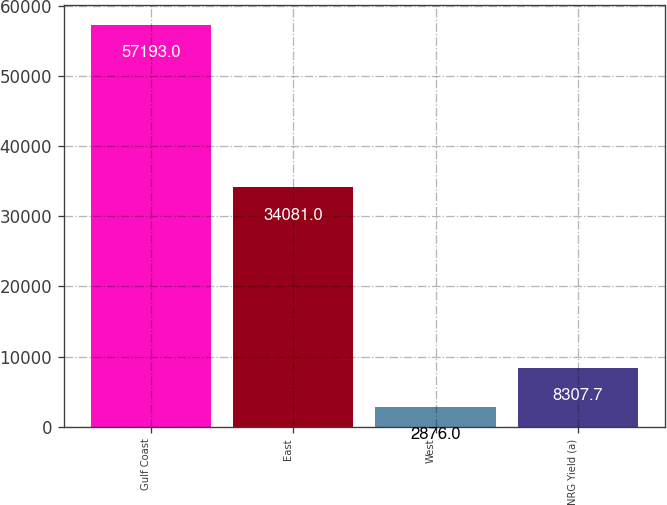<chart> <loc_0><loc_0><loc_500><loc_500><bar_chart><fcel>Gulf Coast<fcel>East<fcel>West<fcel>NRG Yield (a)<nl><fcel>57193<fcel>34081<fcel>2876<fcel>8307.7<nl></chart> 